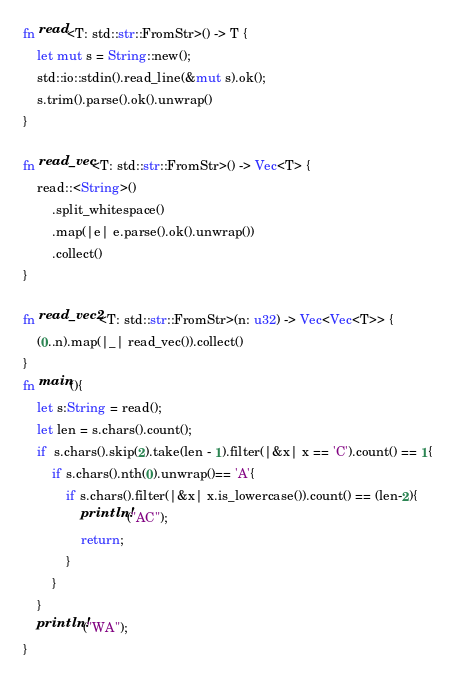Convert code to text. <code><loc_0><loc_0><loc_500><loc_500><_Rust_>fn read<T: std::str::FromStr>() -> T {
    let mut s = String::new();
    std::io::stdin().read_line(&mut s).ok();
    s.trim().parse().ok().unwrap()
}

fn read_vec<T: std::str::FromStr>() -> Vec<T> {
    read::<String>()
        .split_whitespace()
        .map(|e| e.parse().ok().unwrap())
        .collect()
}

fn read_vec2<T: std::str::FromStr>(n: u32) -> Vec<Vec<T>> {
    (0..n).map(|_| read_vec()).collect()
}
fn main(){
    let s:String = read();
    let len = s.chars().count();
    if  s.chars().skip(2).take(len - 1).filter(|&x| x == 'C').count() == 1{
        if s.chars().nth(0).unwrap()== 'A'{
            if s.chars().filter(|&x| x.is_lowercase()).count() == (len-2){
                println!("AC");
                return;
            }
        }
    }
    println!("WA");
}
</code> 